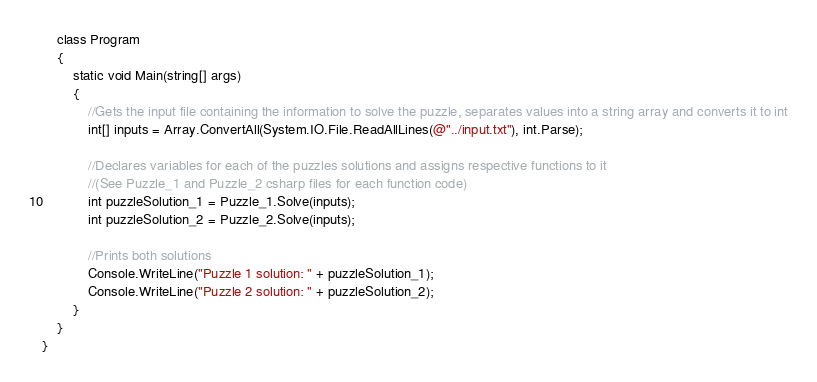<code> <loc_0><loc_0><loc_500><loc_500><_C#_>    class Program
    {
        static void Main(string[] args)
        {
            //Gets the input file containing the information to solve the puzzle, separates values into a string array and converts it to int
            int[] inputs = Array.ConvertAll(System.IO.File.ReadAllLines(@"../input.txt"), int.Parse);

            //Declares variables for each of the puzzles solutions and assigns respective functions to it 
            //(See Puzzle_1 and Puzzle_2 csharp files for each function code)
            int puzzleSolution_1 = Puzzle_1.Solve(inputs);
            int puzzleSolution_2 = Puzzle_2.Solve(inputs);

            //Prints both solutions
            Console.WriteLine("Puzzle 1 solution: " + puzzleSolution_1);
            Console.WriteLine("Puzzle 2 solution: " + puzzleSolution_2);
        }
    }
}</code> 